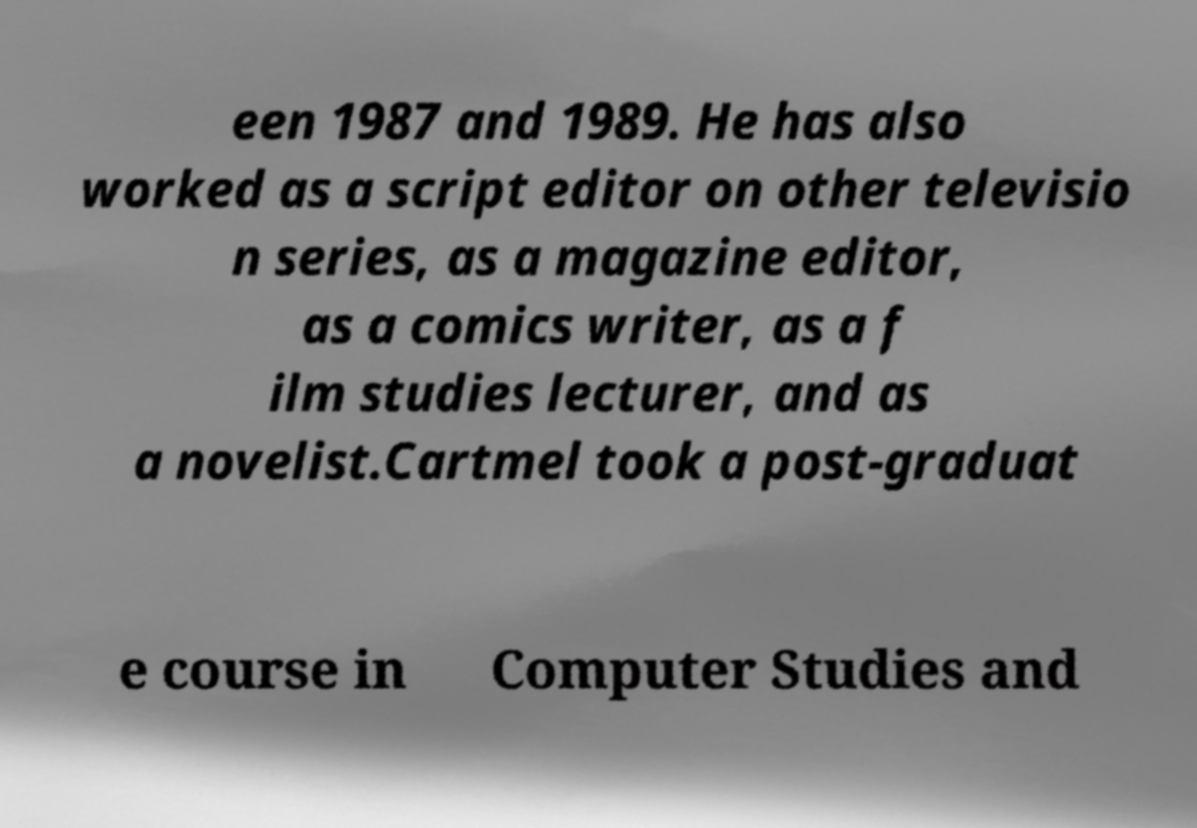For documentation purposes, I need the text within this image transcribed. Could you provide that? een 1987 and 1989. He has also worked as a script editor on other televisio n series, as a magazine editor, as a comics writer, as a f ilm studies lecturer, and as a novelist.Cartmel took a post-graduat e course in Computer Studies and 